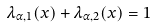Convert formula to latex. <formula><loc_0><loc_0><loc_500><loc_500>\lambda _ { \alpha , 1 } ( x ) + \lambda _ { \alpha , 2 } ( x ) = 1</formula> 